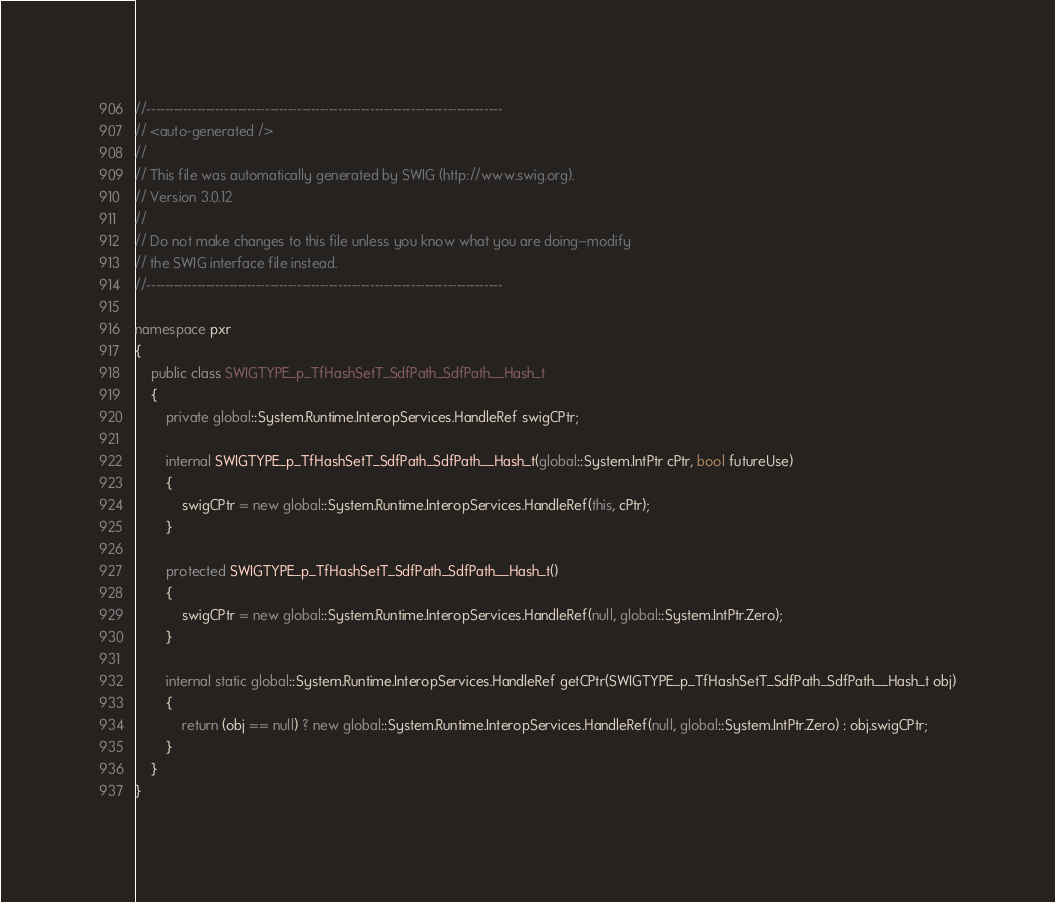Convert code to text. <code><loc_0><loc_0><loc_500><loc_500><_C#_>//------------------------------------------------------------------------------
// <auto-generated />
//
// This file was automatically generated by SWIG (http://www.swig.org).
// Version 3.0.12
//
// Do not make changes to this file unless you know what you are doing--modify
// the SWIG interface file instead.
//------------------------------------------------------------------------------

namespace pxr
{
    public class SWIGTYPE_p_TfHashSetT_SdfPath_SdfPath__Hash_t
    {
        private global::System.Runtime.InteropServices.HandleRef swigCPtr;

        internal SWIGTYPE_p_TfHashSetT_SdfPath_SdfPath__Hash_t(global::System.IntPtr cPtr, bool futureUse)
        {
            swigCPtr = new global::System.Runtime.InteropServices.HandleRef(this, cPtr);
        }

        protected SWIGTYPE_p_TfHashSetT_SdfPath_SdfPath__Hash_t()
        {
            swigCPtr = new global::System.Runtime.InteropServices.HandleRef(null, global::System.IntPtr.Zero);
        }

        internal static global::System.Runtime.InteropServices.HandleRef getCPtr(SWIGTYPE_p_TfHashSetT_SdfPath_SdfPath__Hash_t obj)
        {
            return (obj == null) ? new global::System.Runtime.InteropServices.HandleRef(null, global::System.IntPtr.Zero) : obj.swigCPtr;
        }
    }
}
</code> 